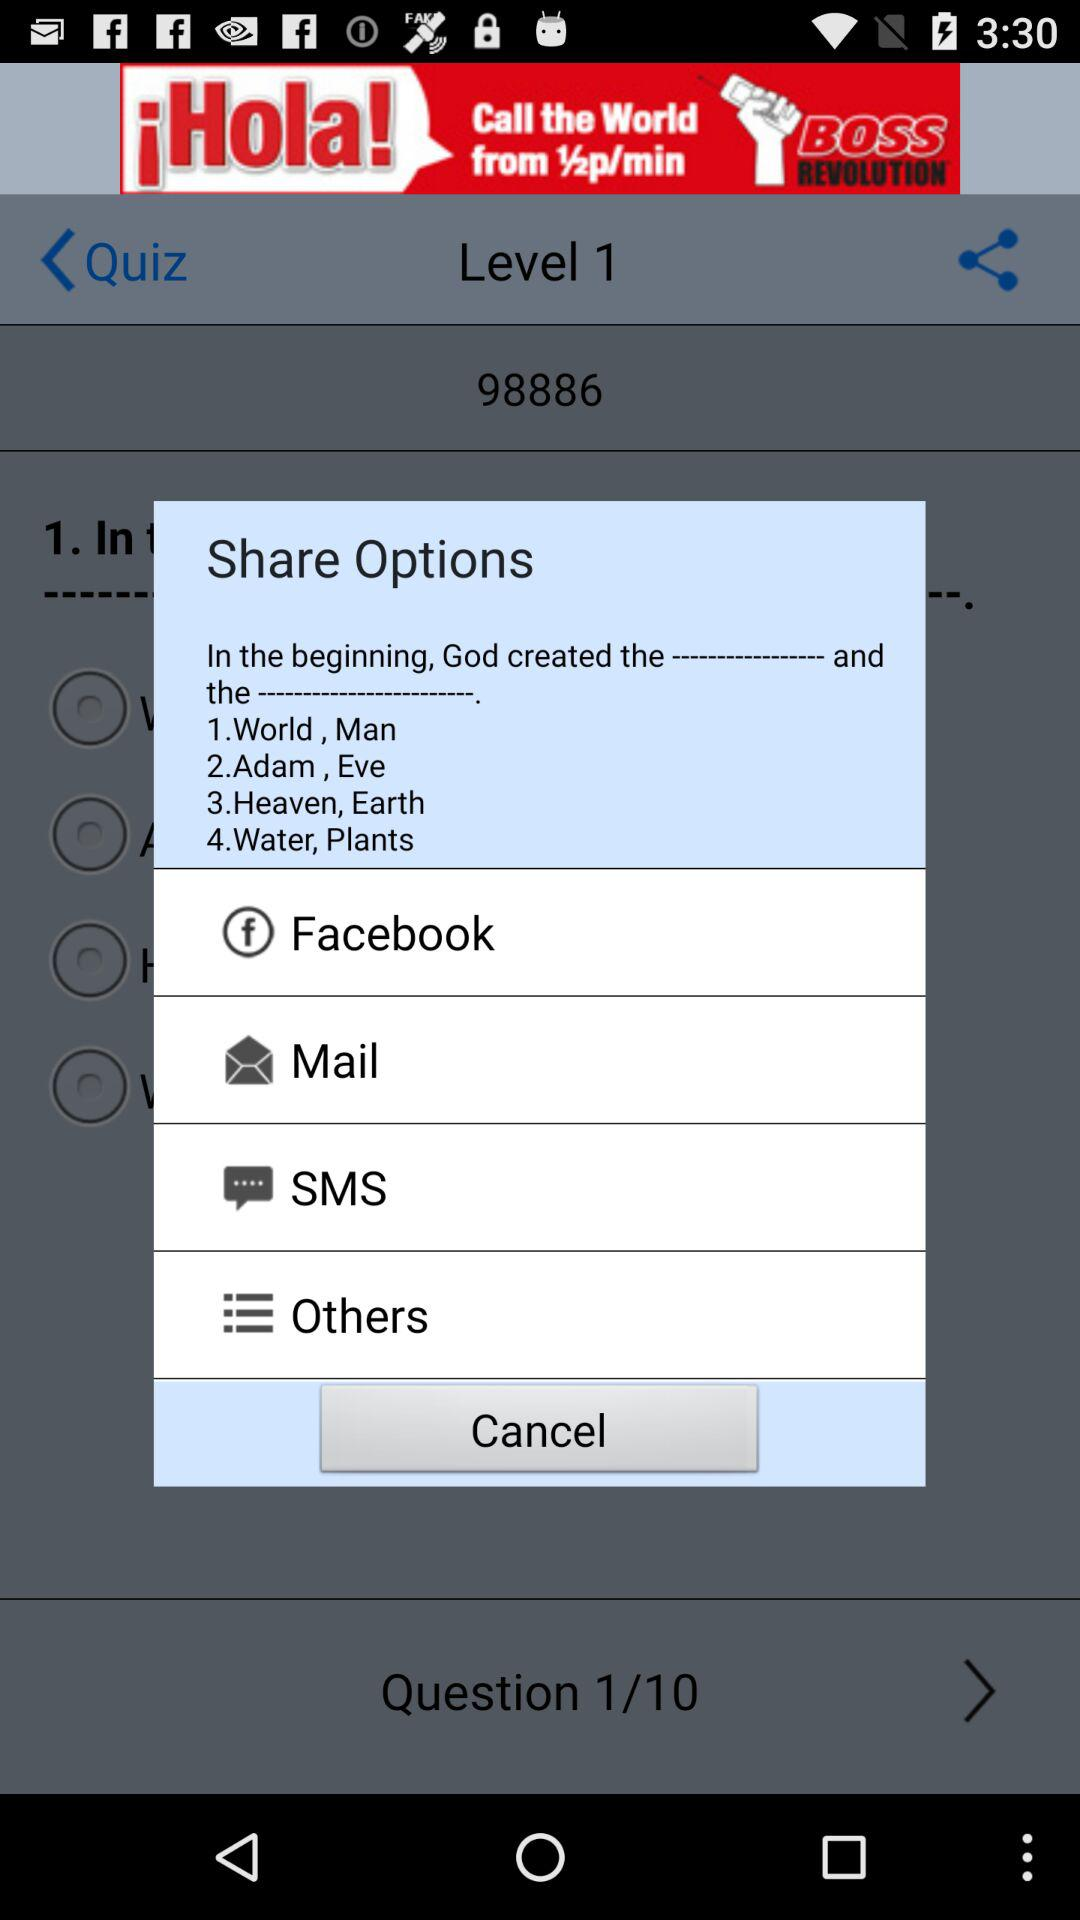What are the apps that can be used to share content? The apps are "Facebook", "Mail", "SMS", and "Others". 